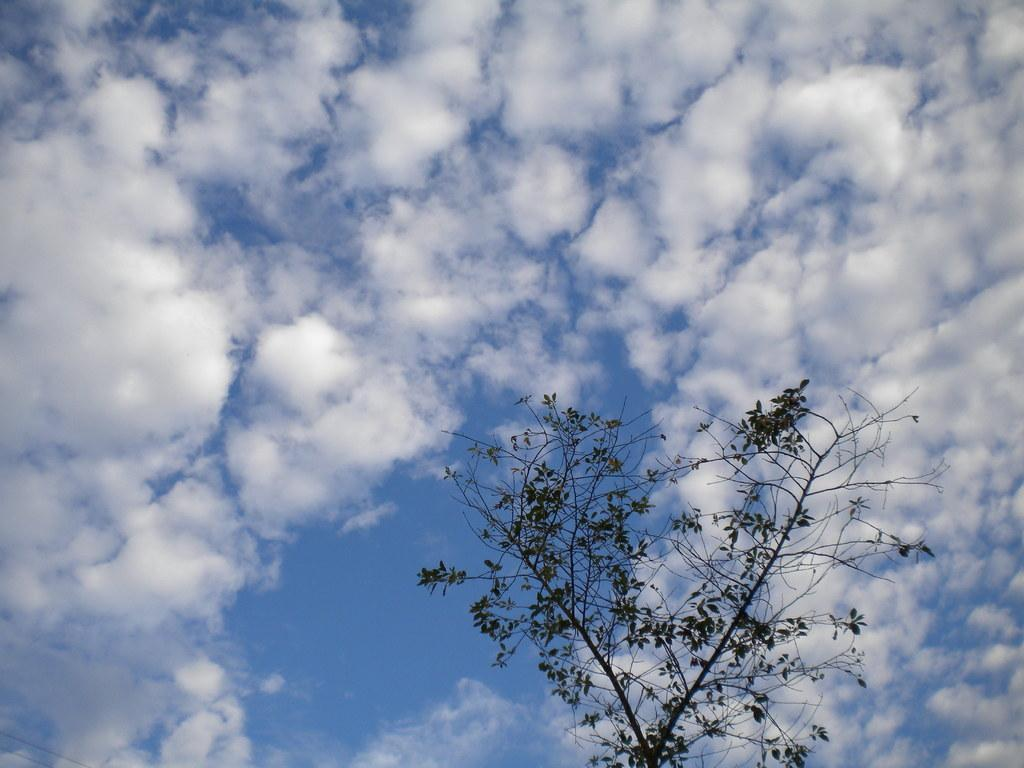What is located at the bottom of the image? There is a tree in the bottom of the image. What can be seen in the background of the image? The sky in the background is cloudy. What type of development is taking place in the image? There is no development or construction activity visible in the image; it primarily features a tree and a cloudy sky. 